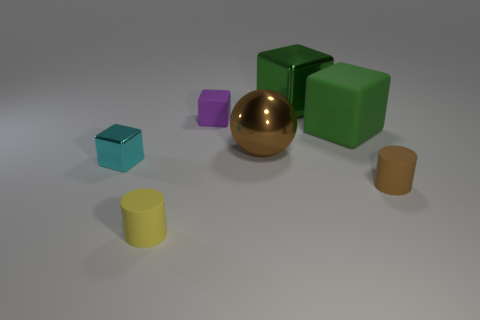Are there any yellow matte things of the same shape as the purple object?
Give a very brief answer. No. There is a large metallic thing behind the big metal object in front of the small purple thing; what is its shape?
Keep it short and to the point. Cube. The small object behind the brown metal ball is what color?
Offer a very short reply. Purple. What size is the green cube that is made of the same material as the large sphere?
Make the answer very short. Large. The brown matte thing that is the same shape as the yellow rubber object is what size?
Your answer should be very brief. Small. Is there a sphere?
Keep it short and to the point. Yes. How many things are either tiny cubes that are in front of the big brown metal ball or small objects?
Your answer should be compact. 4. There is a brown sphere that is the same size as the green metal cube; what is its material?
Your response must be concise. Metal. There is a tiny cylinder to the right of the cylinder that is on the left side of the green matte cube; what color is it?
Provide a succinct answer. Brown. What number of objects are behind the brown rubber thing?
Give a very brief answer. 5. 